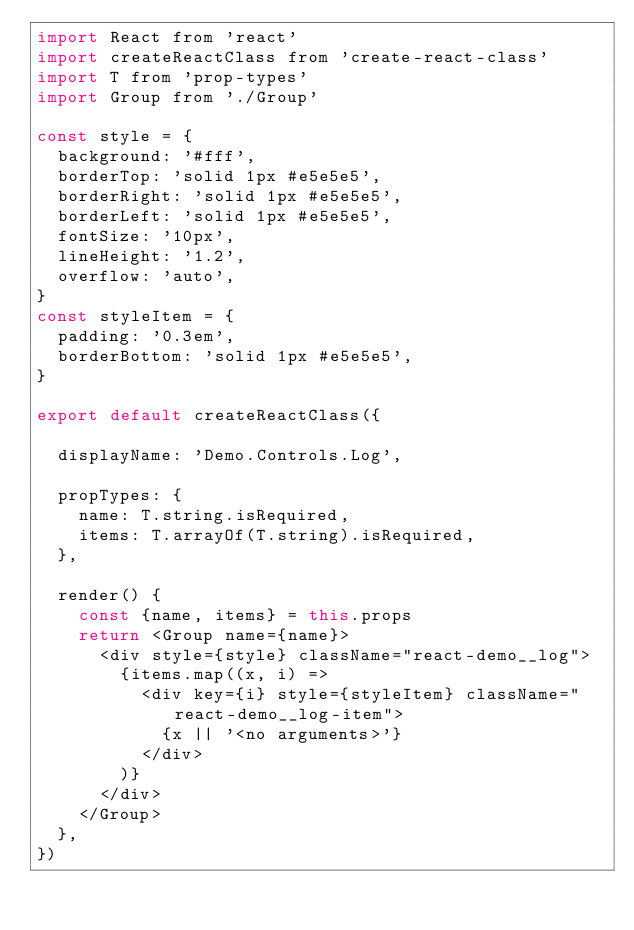<code> <loc_0><loc_0><loc_500><loc_500><_JavaScript_>import React from 'react'
import createReactClass from 'create-react-class'
import T from 'prop-types'
import Group from './Group'

const style = {
  background: '#fff',
  borderTop: 'solid 1px #e5e5e5',
  borderRight: 'solid 1px #e5e5e5',
  borderLeft: 'solid 1px #e5e5e5',
  fontSize: '10px',
  lineHeight: '1.2',
  overflow: 'auto',
}
const styleItem = {
  padding: '0.3em',
  borderBottom: 'solid 1px #e5e5e5',
}

export default createReactClass({

  displayName: 'Demo.Controls.Log',

  propTypes: {
    name: T.string.isRequired,
    items: T.arrayOf(T.string).isRequired,
  },

  render() {
    const {name, items} = this.props
    return <Group name={name}>
      <div style={style} className="react-demo__log">
        {items.map((x, i) =>
          <div key={i} style={styleItem} className="react-demo__log-item">
            {x || '<no arguments>'}
          </div>
        )}
      </div>
    </Group>
  },
})
</code> 